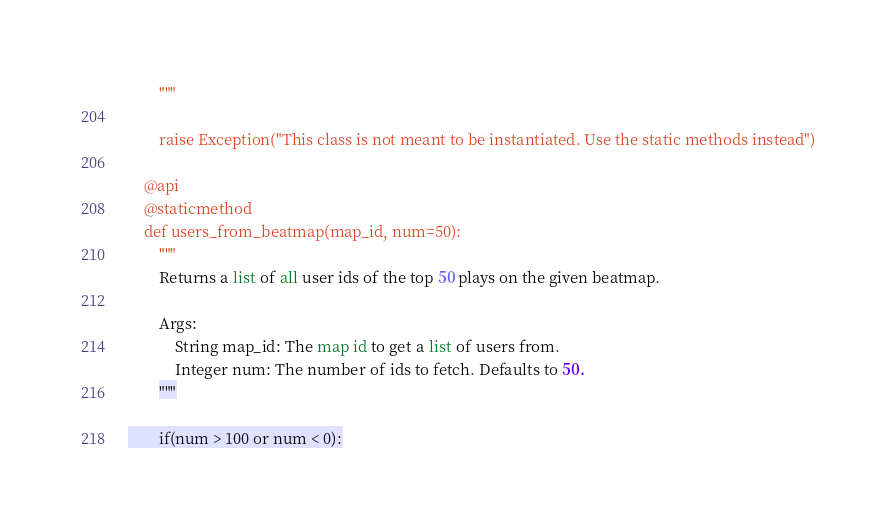Convert code to text. <code><loc_0><loc_0><loc_500><loc_500><_Python_>        """

        raise Exception("This class is not meant to be instantiated. Use the static methods instead")

    @api
    @staticmethod
    def users_from_beatmap(map_id, num=50):
        """
        Returns a list of all user ids of the top 50 plays on the given beatmap.

        Args:
            String map_id: The map id to get a list of users from.
            Integer num: The number of ids to fetch. Defaults to 50.
        """

        if(num > 100 or num < 0):</code> 